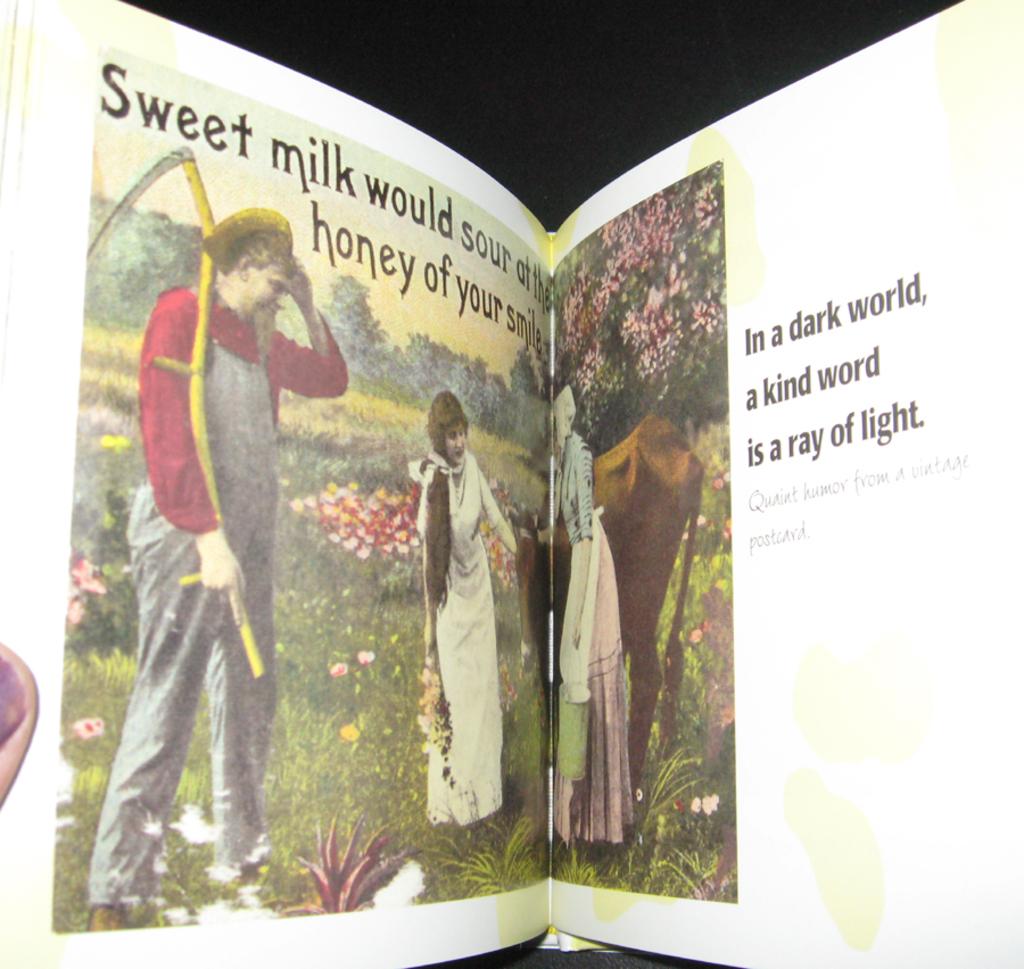What word does the sentence on the left page start with?
Your answer should be very brief. Sweet. On the right page, a ray of light comes from?
Your answer should be compact. A kind word. 